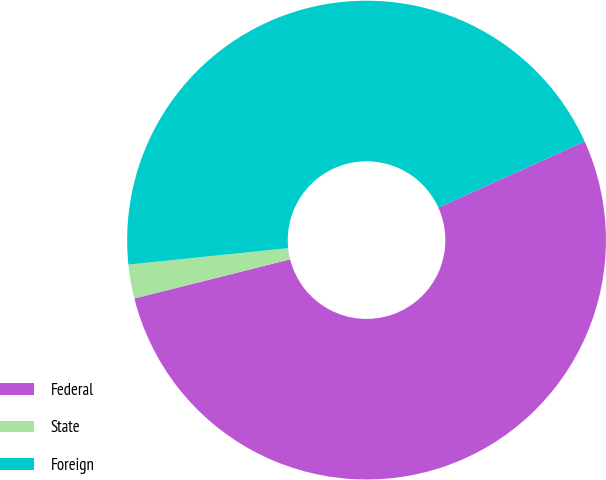Convert chart to OTSL. <chart><loc_0><loc_0><loc_500><loc_500><pie_chart><fcel>Federal<fcel>State<fcel>Foreign<nl><fcel>52.84%<fcel>2.29%<fcel>44.87%<nl></chart> 